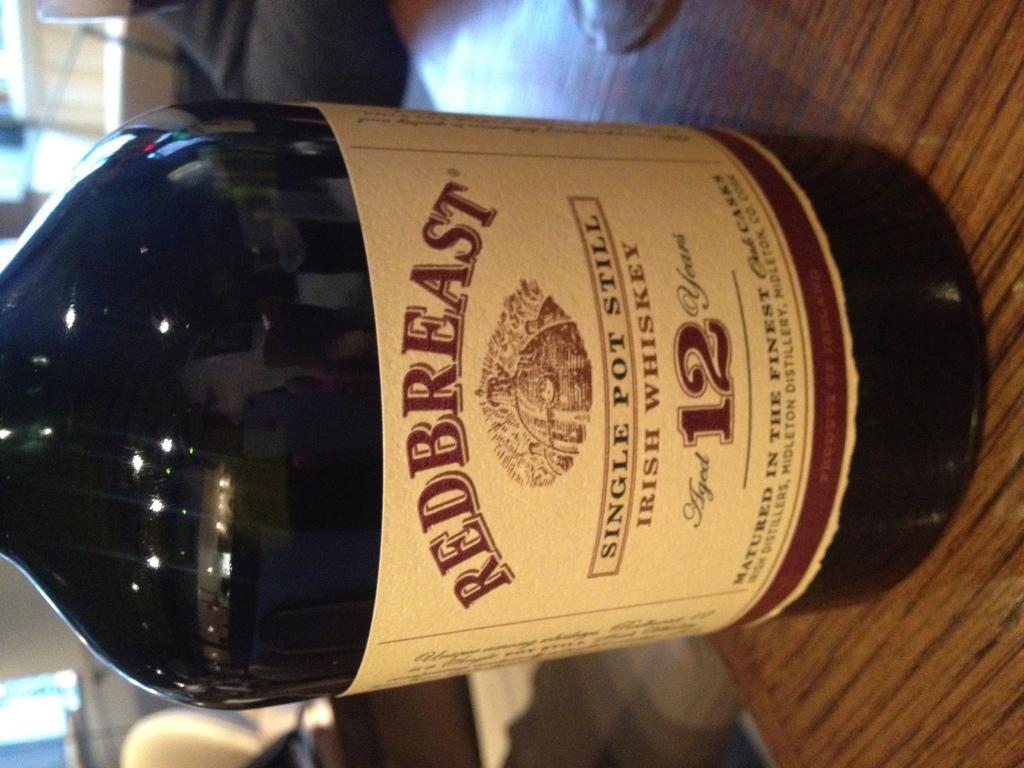Can you describe this image briefly? In this picture there is a bottle and glass on the table and there is text on the label on the bottle. At the back there is a chair and there is might be person behind the table and there are windows. 